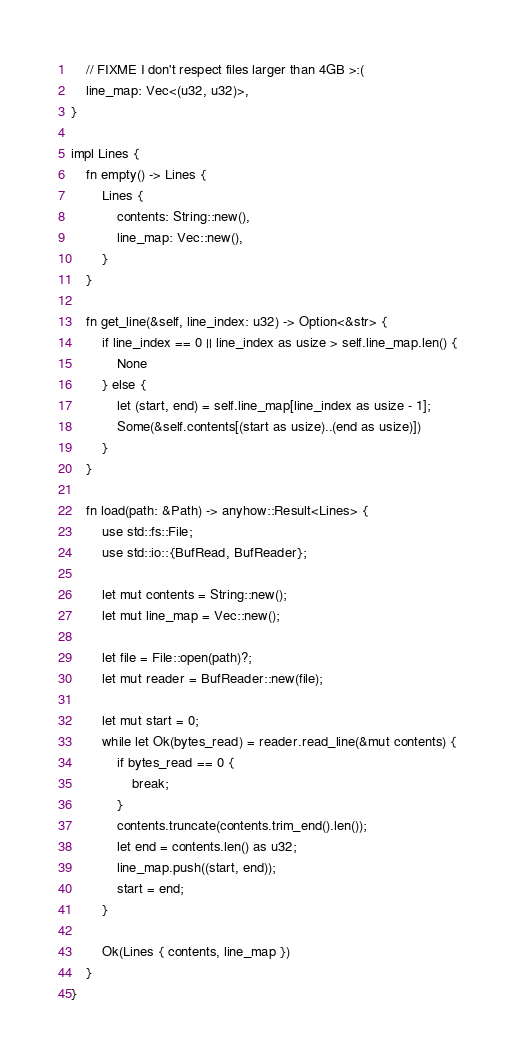<code> <loc_0><loc_0><loc_500><loc_500><_Rust_>
    // FIXME I don't respect files larger than 4GB >:(
    line_map: Vec<(u32, u32)>,
}

impl Lines {
    fn empty() -> Lines {
        Lines {
            contents: String::new(),
            line_map: Vec::new(),
        }
    }

    fn get_line(&self, line_index: u32) -> Option<&str> {
        if line_index == 0 || line_index as usize > self.line_map.len() {
            None
        } else {
            let (start, end) = self.line_map[line_index as usize - 1];
            Some(&self.contents[(start as usize)..(end as usize)])
        }
    }

    fn load(path: &Path) -> anyhow::Result<Lines> {
        use std::fs::File;
        use std::io::{BufRead, BufReader};

        let mut contents = String::new();
        let mut line_map = Vec::new();

        let file = File::open(path)?;
        let mut reader = BufReader::new(file);

        let mut start = 0;
        while let Ok(bytes_read) = reader.read_line(&mut contents) {
            if bytes_read == 0 {
                break;
            }
            contents.truncate(contents.trim_end().len());
            let end = contents.len() as u32;
            line_map.push((start, end));
            start = end;
        }

        Ok(Lines { contents, line_map })
    }
}
</code> 